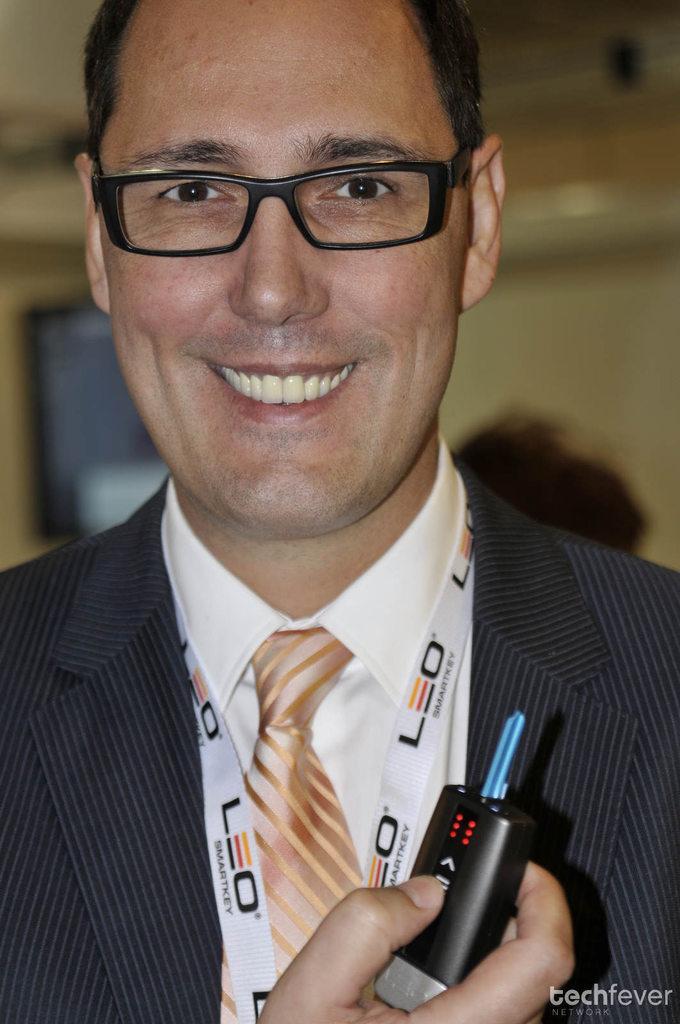In one or two sentences, can you explain what this image depicts? In this image I can see the person wearing the black, white color dress and the brown color tie. The person is wearing the specs and holding the black color object. And there is a blurred background. 